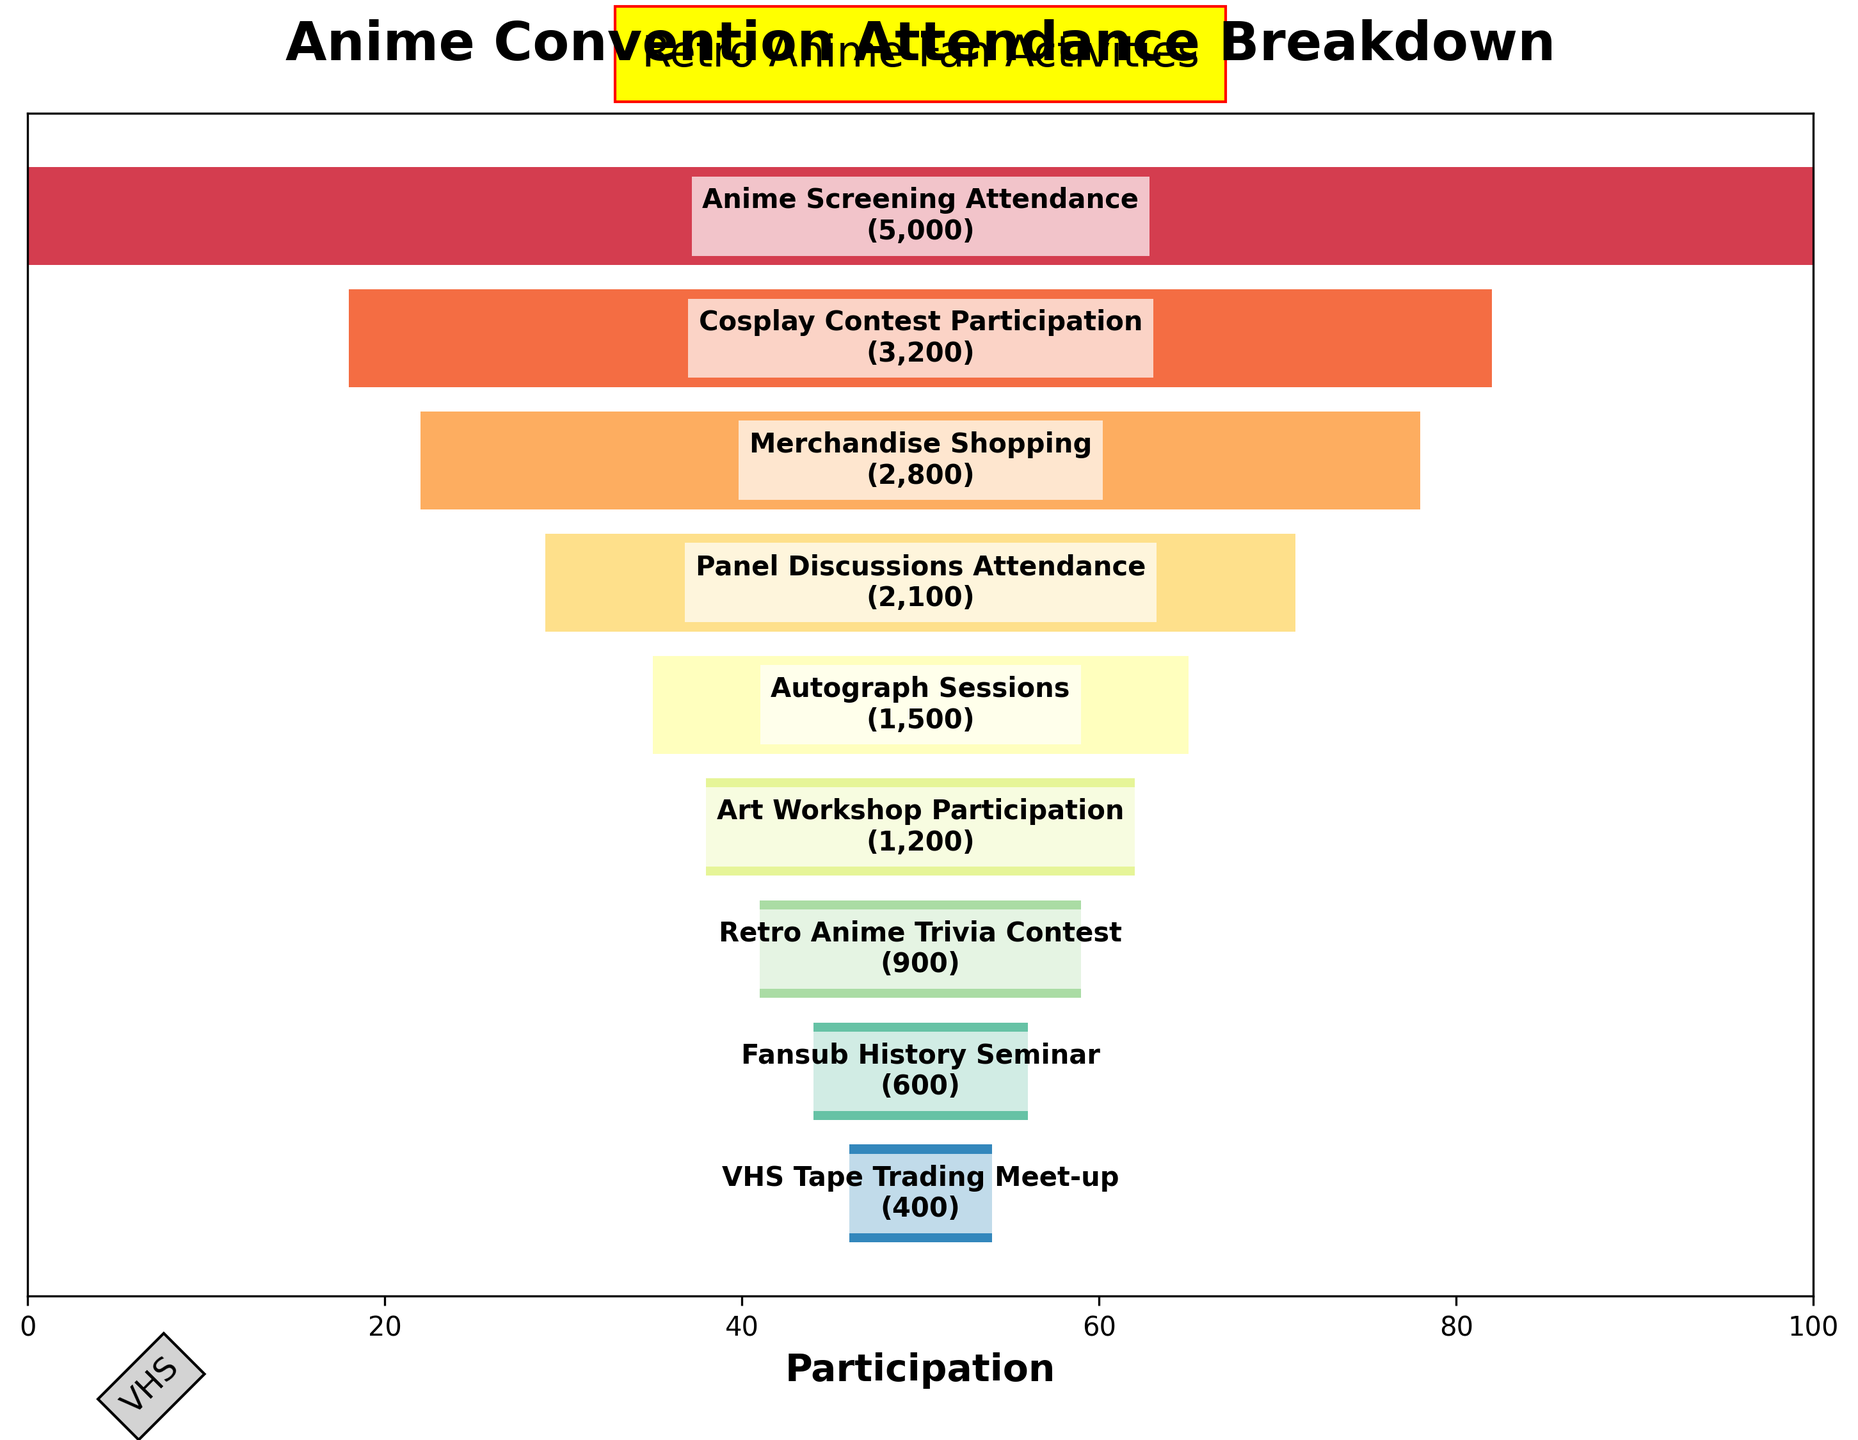What's the title of the plot? The title is prominently displayed at the top of the plot, usually in a larger and bolder font compared to other text elements.
Answer: Anime Convention Attendance Breakdown How many activities are listed in the plot? Count the number of horizontal bars representing different activities. Each bar corresponds to an activity listed along with the participation numbers.
Answer: 9 Which activity has the highest number of participants? Identify the widest horizontal bar in the funnel chart, as the width indicates the number of participants. The activity name will be labeled on or near this widest bar.
Answer: Anime Screening Attendance How many participants attended the retro anime trivia contest? Locate the bar labeled "Retro Anime Trivia Contest" and read the number of participants given in parentheses next to the activity name.
Answer: 900 What's the participation difference between the cosplay contest and merchandise shopping? Look at the participation numbers for both "Cosplay Contest Participation" and "Merchandise Shopping". Subtract the smaller number from the larger one to find the difference.
Answer: 400 Which activity had fewer participants: autograph sessions or panel discussions? Compare the width and the participant numbers of the bars labeled "Autograph Sessions" and "Panel Discussions Attendance" to determine which has fewer participants.
Answer: Autograph Sessions What's the average number of participants across all activities? Sum the number of participants for all activities and divide by the total number of activities. (5000 + 3200 + 2800 + 2100 + 1500 + 1200 + 900 + 600 + 400) / 9 = 1978
Answer: 1978 What's the relative percentage of participants attending art workshop participation compared to anime screening attendance? Calculate the percentage by dividing the number of participants in "Art Workshop Participation" by the number of participants in "Anime Screening Attendance" and multiplying by 100. (1200 / 5000) * 100 = 24%
Answer: 24% Which activities have fewer than 1000 participants? Identify the bars where the participant numbers are less than 1000 and list those activities.
Answer: Retro Anime Trivia Contest, Fansub History Seminar, VHS Tape Trading Meet-up What's the total number of participants in the lower three activities combined? Sum the number of participants for the bottom three activities in terms of participant numbers: "Fansub History Seminar", "Retro Anime Trivia Contest", and "VHS Tape Trading Meet-up". 600 + 900 + 400 = 1900
Answer: 1900 